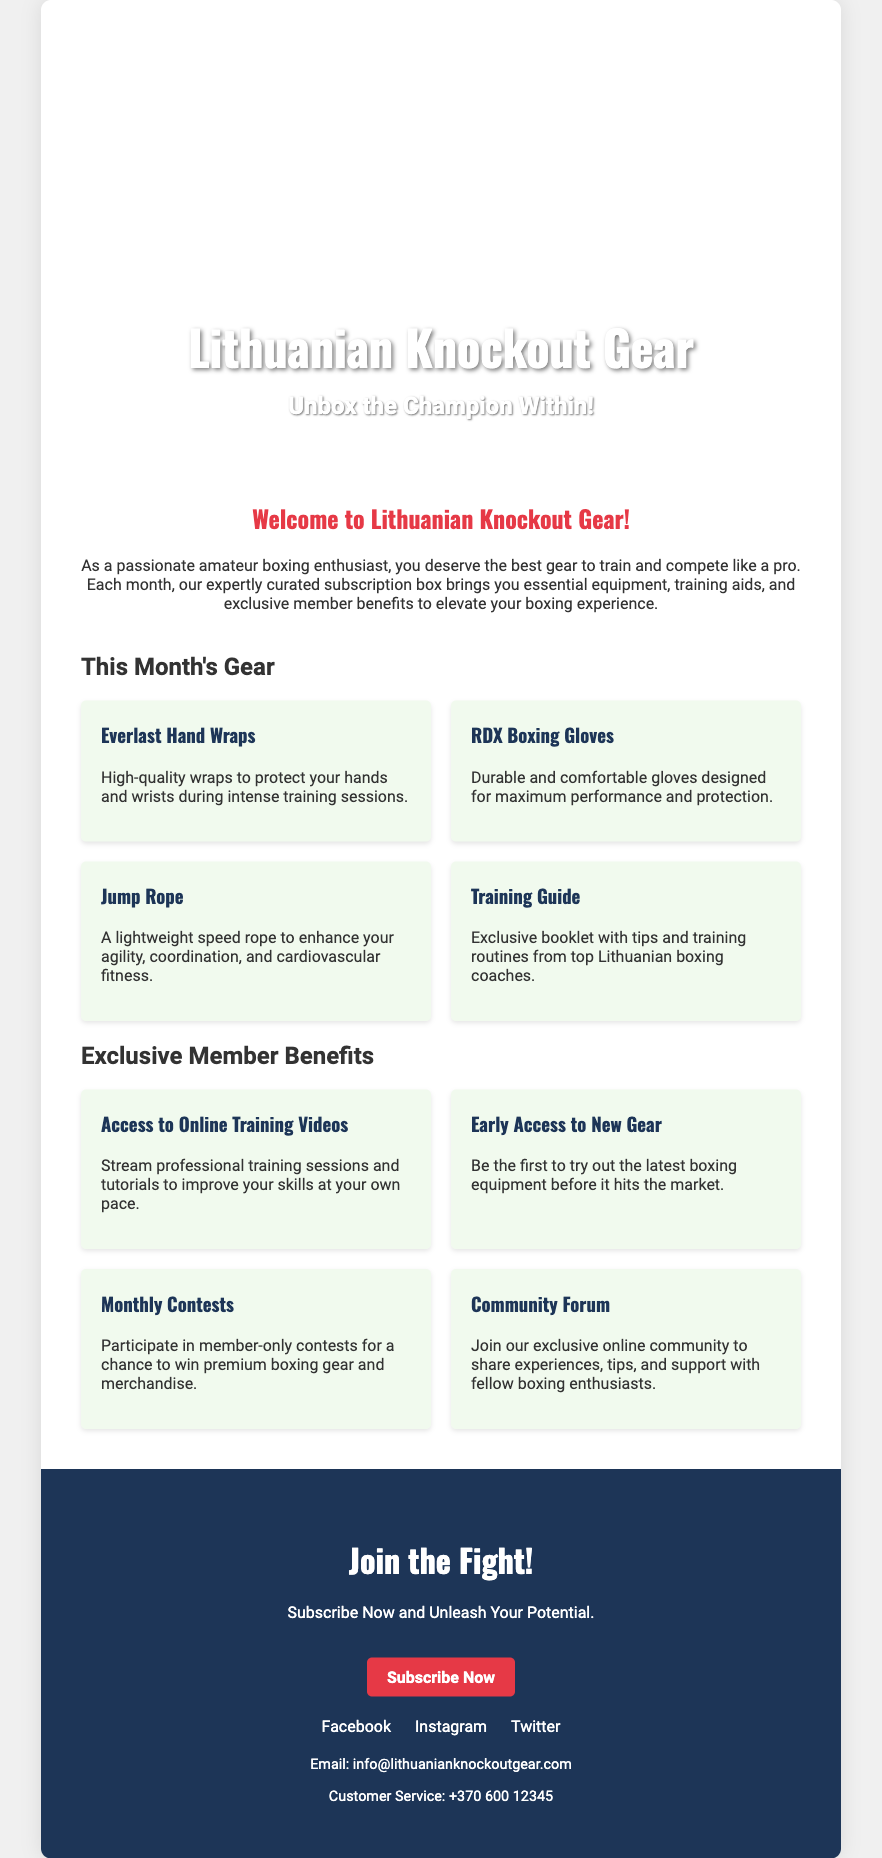what is the title of the subscription box? The title of the subscription box is prominently displayed on the front cover of the document.
Answer: Lithuanian Knockout Gear what items are included in this month's gear? The items listed are presented in a section specifically dedicated to the gear.
Answer: Everlast Hand Wraps, RDX Boxing Gloves, Jump Rope, Training Guide how many exclusive member benefits are mentioned? The number of benefits can be found in the section listing them.
Answer: Four what is the main benefit of the Training Guide? The benefit of the Training Guide is described in the context of its purpose.
Answer: Exclusive booklet with tips and training routines what is the promotion offered in the document? The promotion is related to joining or subscribing to the service highlighted in the back cover.
Answer: Join the Fight! what type of content can members access? This question refers to the specific content availability for members indicated in the document.
Answer: Online Training Videos which social media platforms are mentioned in the document? The platforms are listed in relation to their link accessibility in the social media section.
Answer: Facebook, Instagram, Twitter what is the phone number for customer service? The phone number can be found in the additional info section.
Answer: +370 600 12345 what is the call to action in the back cover? The call to action is explicitly stated in the context of encouraging subscriptions.
Answer: Subscribe Now 